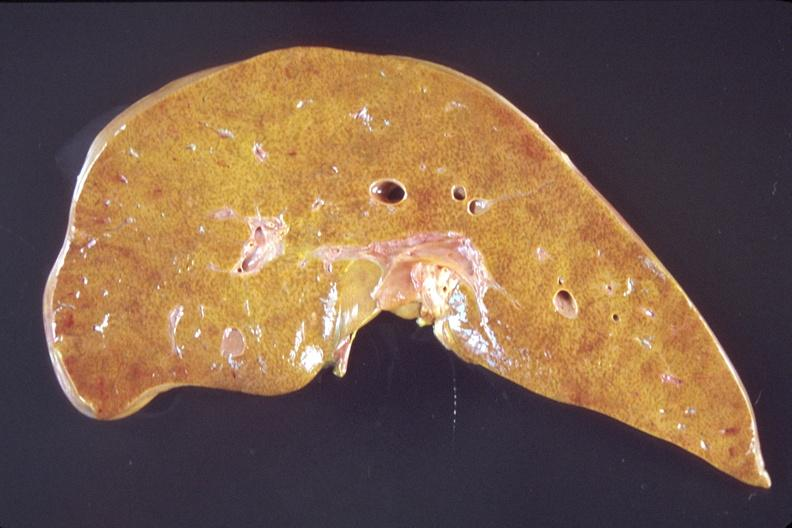what is present?
Answer the question using a single word or phrase. Hepatobiliary 